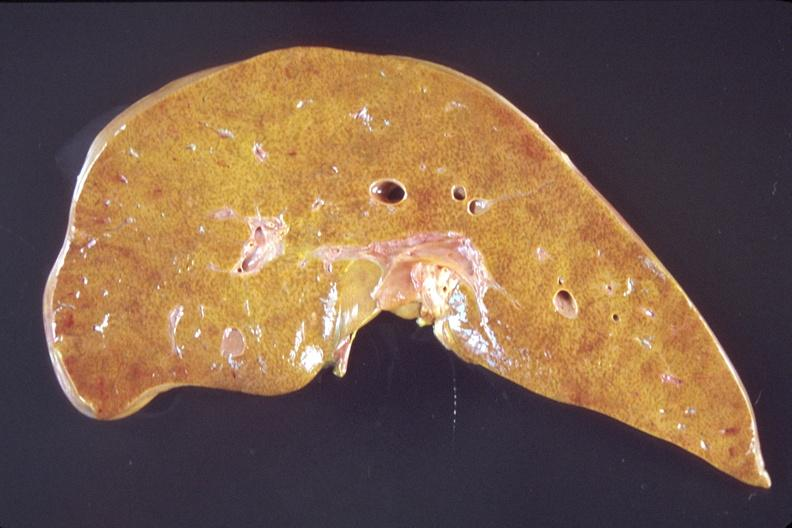what is present?
Answer the question using a single word or phrase. Hepatobiliary 